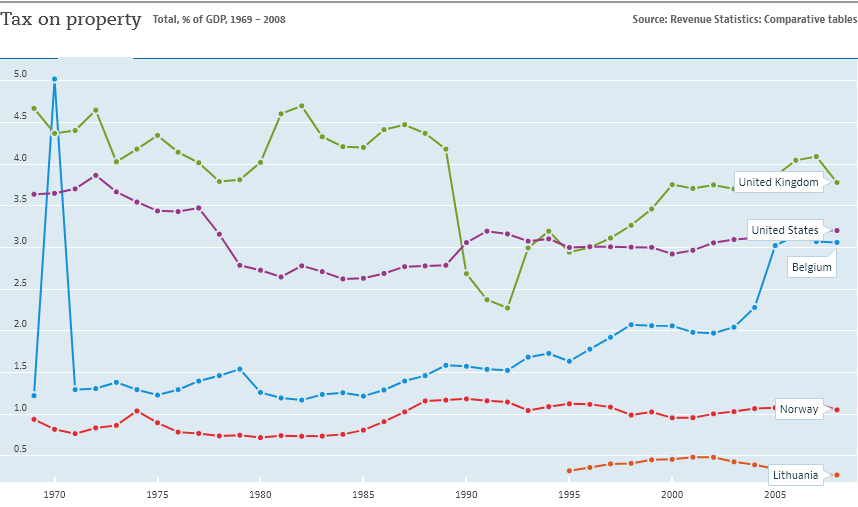Give some essential details in this illustration. Five countries are depicted in the bar graph. In 1990, the United States and the United Kingdom intersect. 